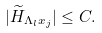Convert formula to latex. <formula><loc_0><loc_0><loc_500><loc_500>| \widetilde { H } _ { \Lambda _ { l } x _ { j } } | \leq C .</formula> 